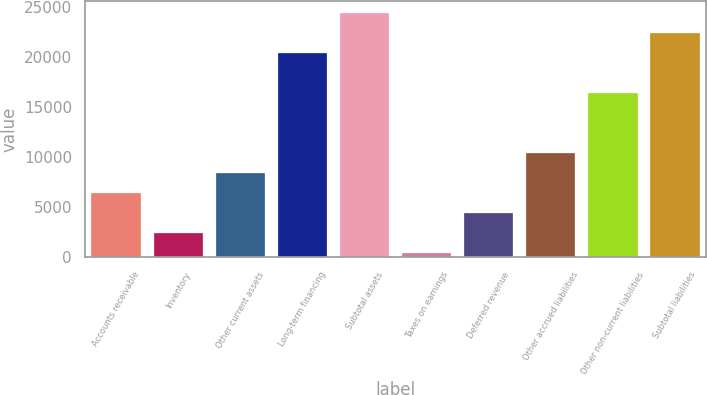Convert chart. <chart><loc_0><loc_0><loc_500><loc_500><bar_chart><fcel>Accounts receivable<fcel>Inventory<fcel>Other current assets<fcel>Long-term financing<fcel>Subtotal assets<fcel>Taxes on earnings<fcel>Deferred revenue<fcel>Other accrued liabilities<fcel>Other non-current liabilities<fcel>Subtotal liabilities<nl><fcel>6441.2<fcel>2447<fcel>8438.3<fcel>20420.9<fcel>24415.1<fcel>378<fcel>4444.1<fcel>10435.4<fcel>16426.7<fcel>22418<nl></chart> 